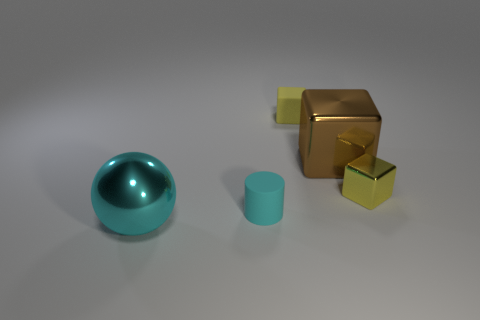Subtract all tiny yellow matte blocks. How many blocks are left? 2 Subtract all yellow cubes. How many cubes are left? 1 Add 4 yellow things. How many objects exist? 9 Subtract all cubes. How many objects are left? 2 Subtract 2 cubes. How many cubes are left? 1 Subtract all blue cylinders. How many red blocks are left? 0 Subtract all cylinders. Subtract all yellow matte blocks. How many objects are left? 3 Add 5 spheres. How many spheres are left? 6 Add 5 purple things. How many purple things exist? 5 Subtract 0 cyan cubes. How many objects are left? 5 